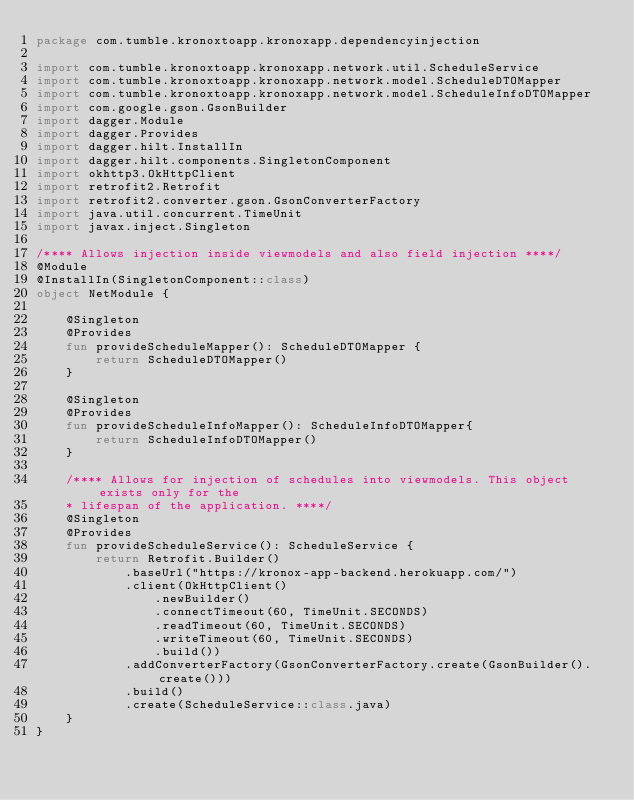<code> <loc_0><loc_0><loc_500><loc_500><_Kotlin_>package com.tumble.kronoxtoapp.kronoxapp.dependencyinjection

import com.tumble.kronoxtoapp.kronoxapp.network.util.ScheduleService
import com.tumble.kronoxtoapp.kronoxapp.network.model.ScheduleDTOMapper
import com.tumble.kronoxtoapp.kronoxapp.network.model.ScheduleInfoDTOMapper
import com.google.gson.GsonBuilder
import dagger.Module
import dagger.Provides
import dagger.hilt.InstallIn
import dagger.hilt.components.SingletonComponent
import okhttp3.OkHttpClient
import retrofit2.Retrofit
import retrofit2.converter.gson.GsonConverterFactory
import java.util.concurrent.TimeUnit
import javax.inject.Singleton

/**** Allows injection inside viewmodels and also field injection ****/
@Module
@InstallIn(SingletonComponent::class)
object NetModule {

    @Singleton
    @Provides
    fun provideScheduleMapper(): ScheduleDTOMapper {
        return ScheduleDTOMapper()
    }

    @Singleton
    @Provides
    fun provideScheduleInfoMapper(): ScheduleInfoDTOMapper{
        return ScheduleInfoDTOMapper()
    }

    /**** Allows for injection of schedules into viewmodels. This object exists only for the
    * lifespan of the application. ****/
    @Singleton
    @Provides
    fun provideScheduleService(): ScheduleService {
        return Retrofit.Builder()
            .baseUrl("https://kronox-app-backend.herokuapp.com/")
            .client(OkHttpClient()
                .newBuilder()
                .connectTimeout(60, TimeUnit.SECONDS)
                .readTimeout(60, TimeUnit.SECONDS)
                .writeTimeout(60, TimeUnit.SECONDS)
                .build())
            .addConverterFactory(GsonConverterFactory.create(GsonBuilder().create()))
            .build()
            .create(ScheduleService::class.java)
    }
}</code> 